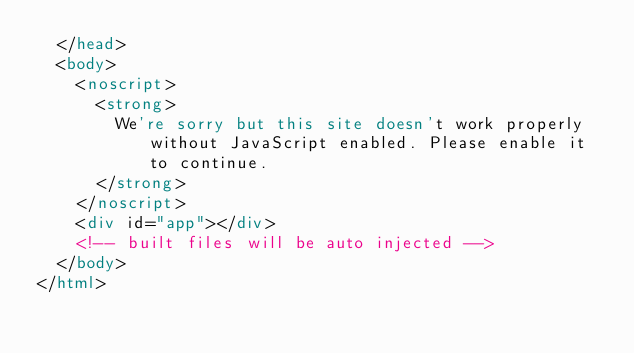Convert code to text. <code><loc_0><loc_0><loc_500><loc_500><_HTML_>  </head>
  <body>
    <noscript>
      <strong>
        We're sorry but this site doesn't work properly without JavaScript enabled. Please enable it to continue.
      </strong>
    </noscript>
    <div id="app"></div>
    <!-- built files will be auto injected -->
  </body>
</html>
</code> 